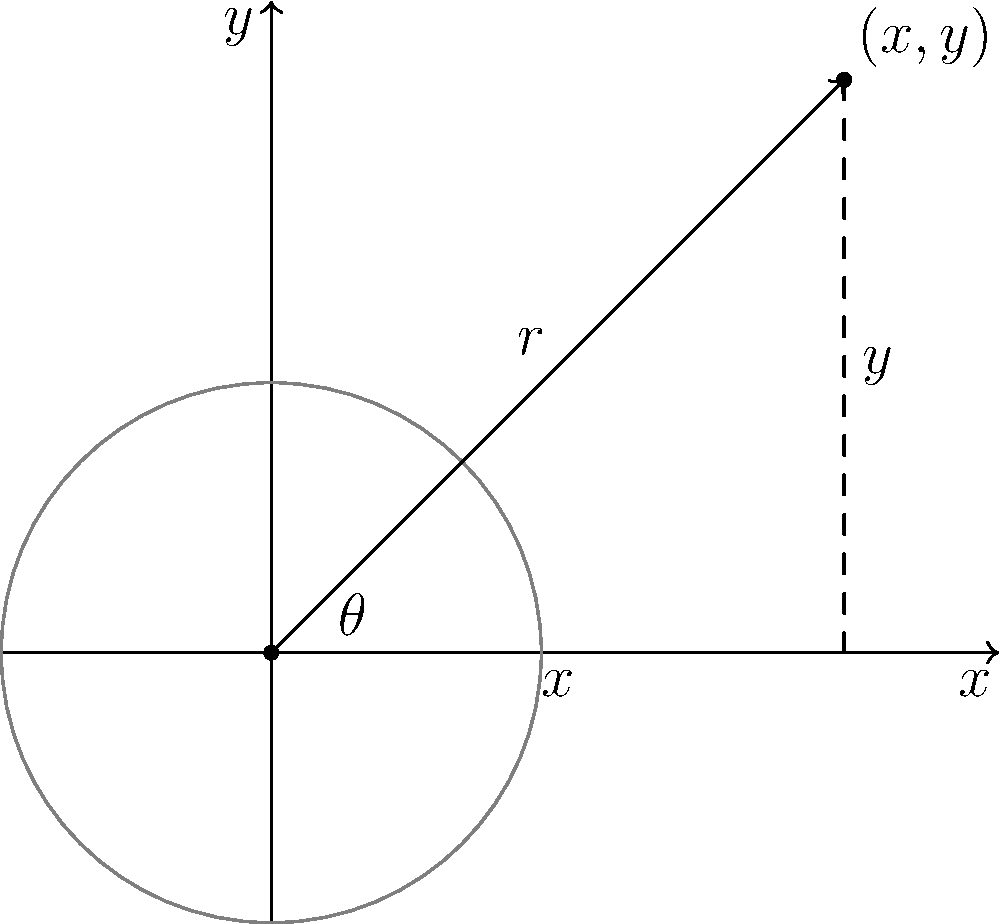Given a JSON-RPC request to convert polar coordinates $(r,\theta)=(3,\frac{\pi}{4})$ to Cartesian coordinates, what would be the correct JSON-RPC response format for the calculated $(x,y)$ values? To solve this problem, let's follow these steps:

1. Understand the conversion formulas:
   $x = r \cos(\theta)$
   $y = r \sin(\theta)$

2. Calculate the values:
   $x = 3 \cos(\frac{\pi}{4}) \approx 2.12132$
   $y = 3 \sin(\frac{\pi}{4}) \approx 2.12132$

3. Recall the JSON-RPC response format:
   ```
   {
     "jsonrpc": "2.0",
     "result": {
       "x": value,
       "y": value
     },
     "id": request_id
   }
   ```

4. Fill in the calculated values:
   ```
   {
     "jsonrpc": "2.0",
     "result": {
       "x": 2.12132,
       "y": 2.12132
     },
     "id": 1
   }
   ```

Note: The `id` value should match the id sent in the request. Here, we've used 1 as an example.
Answer: {"jsonrpc":"2.0","result":{"x":2.12132,"y":2.12132},"id":1} 